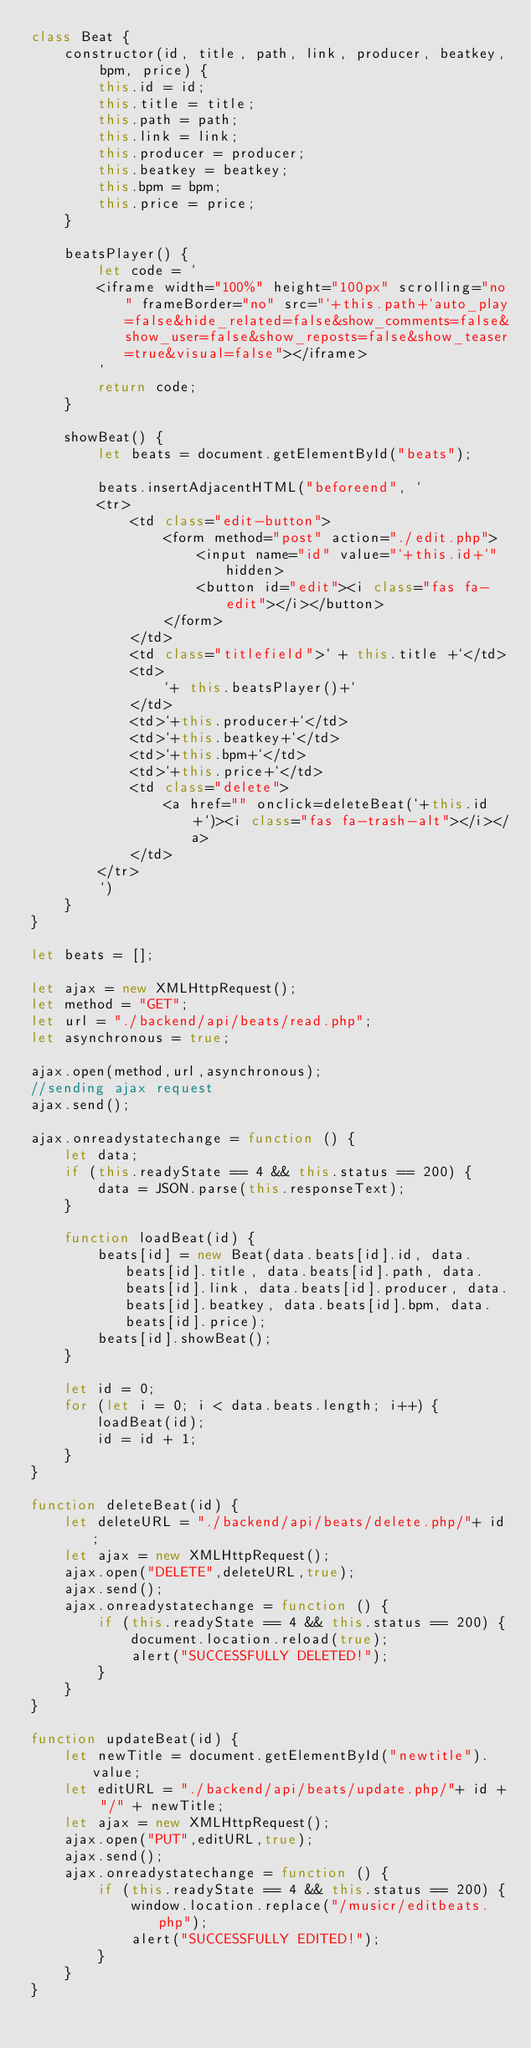Convert code to text. <code><loc_0><loc_0><loc_500><loc_500><_JavaScript_>class Beat {
    constructor(id, title, path, link, producer, beatkey, bpm, price) {
        this.id = id;
        this.title = title;
        this.path = path;
        this.link = link;
        this.producer = producer;
        this.beatkey = beatkey;
        this.bpm = bpm;
        this.price = price;
    }

    beatsPlayer() {
        let code = `
        <iframe width="100%" height="100px" scrolling="no" frameBorder="no" src="`+this.path+`auto_play=false&hide_related=false&show_comments=false&show_user=false&show_reposts=false&show_teaser=true&visual=false"></iframe>
        `
        return code;
    }

    showBeat() {
        let beats = document.getElementById("beats");

        beats.insertAdjacentHTML("beforeend", ` 
        <tr>
            <td class="edit-button">
                <form method="post" action="./edit.php">
                    <input name="id" value="`+this.id+`" hidden>
                    <button id="edit"><i class="fas fa-edit"></i></button>
                </form>
            </td> 
            <td class="titlefield">` + this.title +`</td>
            <td>
                `+ this.beatsPlayer()+`
            </td>       
            <td>`+this.producer+`</td>
            <td>`+this.beatkey+`</td>
            <td>`+this.bpm+`</td>
            <td>`+this.price+`</td>
            <td class="delete">
                <a href="" onclick=deleteBeat(`+this.id+`)><i class="fas fa-trash-alt"></i></a>
            </td>
        </tr>
        `)
    }
}

let beats = [];

let ajax = new XMLHttpRequest();
let method = "GET";
let url = "./backend/api/beats/read.php";
let asynchronous = true;

ajax.open(method,url,asynchronous);
//sending ajax request
ajax.send();

ajax.onreadystatechange = function () {
    let data;
    if (this.readyState == 4 && this.status == 200) {
        data = JSON.parse(this.responseText);
    }

    function loadBeat(id) {
        beats[id] = new Beat(data.beats[id].id, data.beats[id].title, data.beats[id].path, data.beats[id].link, data.beats[id].producer, data.beats[id].beatkey, data.beats[id].bpm, data.beats[id].price);
        beats[id].showBeat();
    }

    let id = 0;
    for (let i = 0; i < data.beats.length; i++) {
        loadBeat(id);
        id = id + 1;
    }
}

function deleteBeat(id) {
    let deleteURL = "./backend/api/beats/delete.php/"+ id;
    let ajax = new XMLHttpRequest();
    ajax.open("DELETE",deleteURL,true);
    ajax.send();
    ajax.onreadystatechange = function () {
        if (this.readyState == 4 && this.status == 200) {
            document.location.reload(true);
            alert("SUCCESSFULLY DELETED!");
        }
    }
}

function updateBeat(id) {
    let newTitle = document.getElementById("newtitle").value;
    let editURL = "./backend/api/beats/update.php/"+ id + "/" + newTitle;
    let ajax = new XMLHttpRequest();
    ajax.open("PUT",editURL,true);
    ajax.send();
    ajax.onreadystatechange = function () {
        if (this.readyState == 4 && this.status == 200) {
            window.location.replace("/musicr/editbeats.php");
            alert("SUCCESSFULLY EDITED!");
        }
    }
}
</code> 